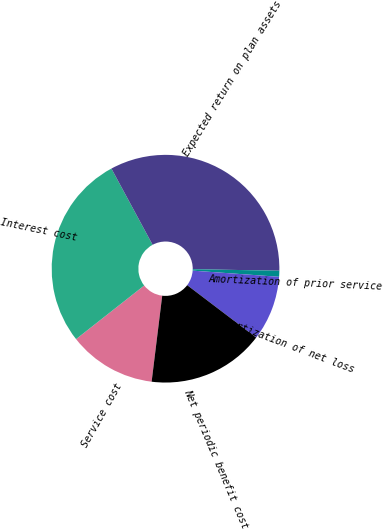Convert chart. <chart><loc_0><loc_0><loc_500><loc_500><pie_chart><fcel>Service cost<fcel>Interest cost<fcel>Expected return on plan assets<fcel>Amortization of prior service<fcel>Amortization of net loss<fcel>Net periodic benefit cost<nl><fcel>12.44%<fcel>27.73%<fcel>33.17%<fcel>0.85%<fcel>9.21%<fcel>16.61%<nl></chart> 